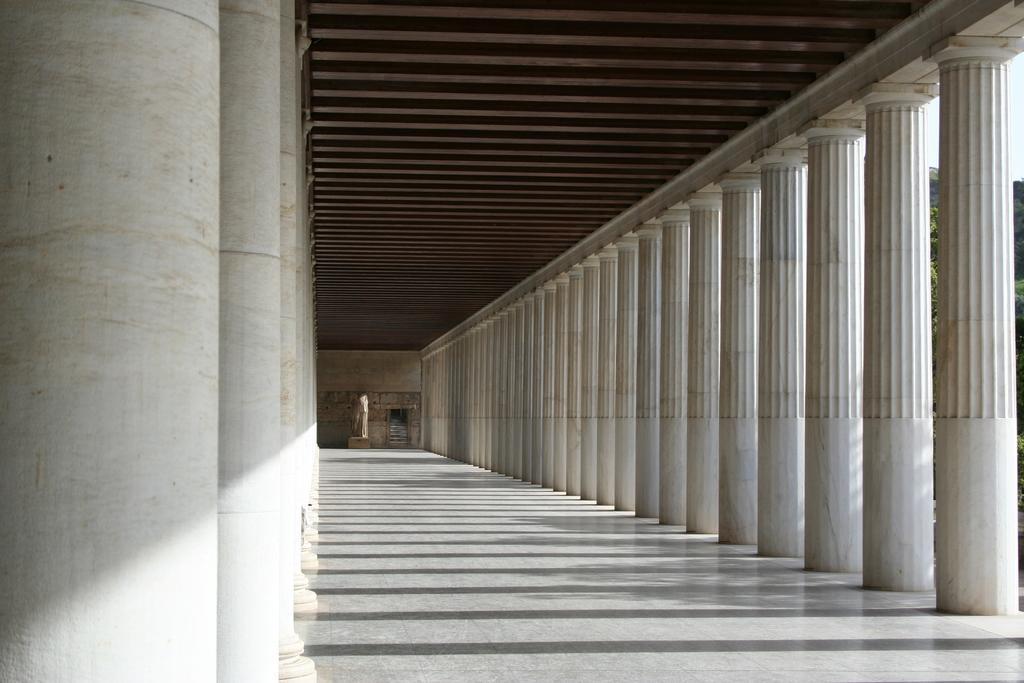Can you describe this image briefly? In this image we can see a corridor, pillars, trees and sky. 